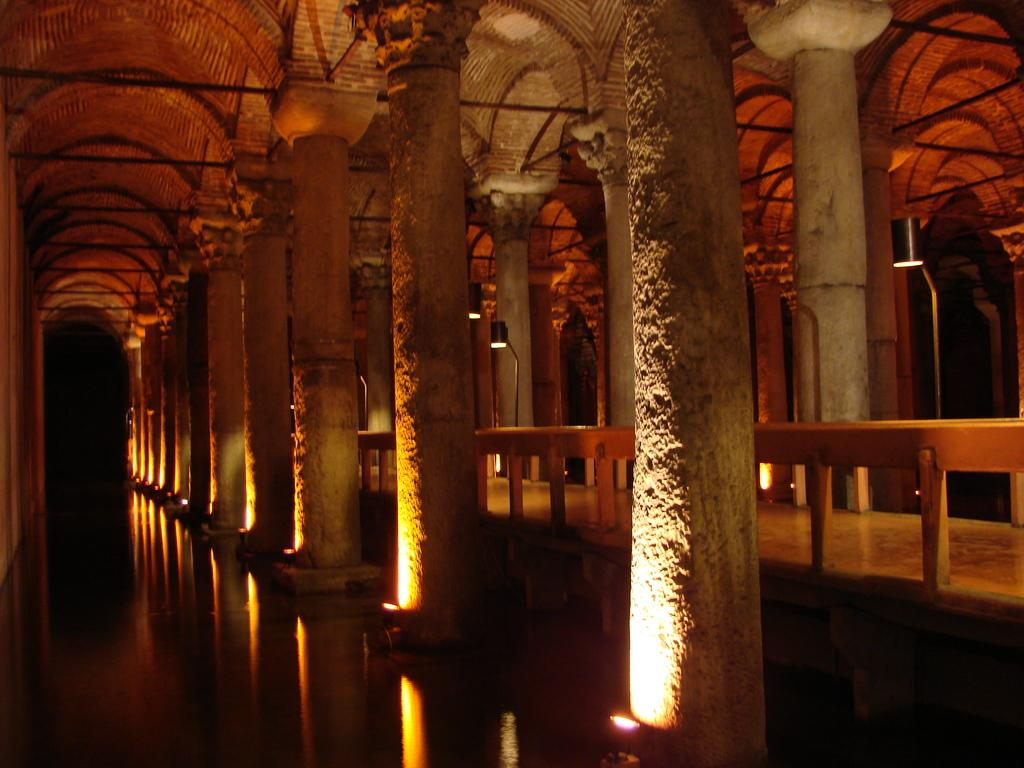What can be found in the center of the image? There are pillars and lights in the center of the image. What is located on the left side of the image? There is water on the left side of the image. What elements are present on the right side of the image? There is fencing, pillars, and lights on the right side of the image. What type of industry can be seen in the image? There is no industry present in the image. Is there any evidence of war in the image? There is no evidence of war in the image. 